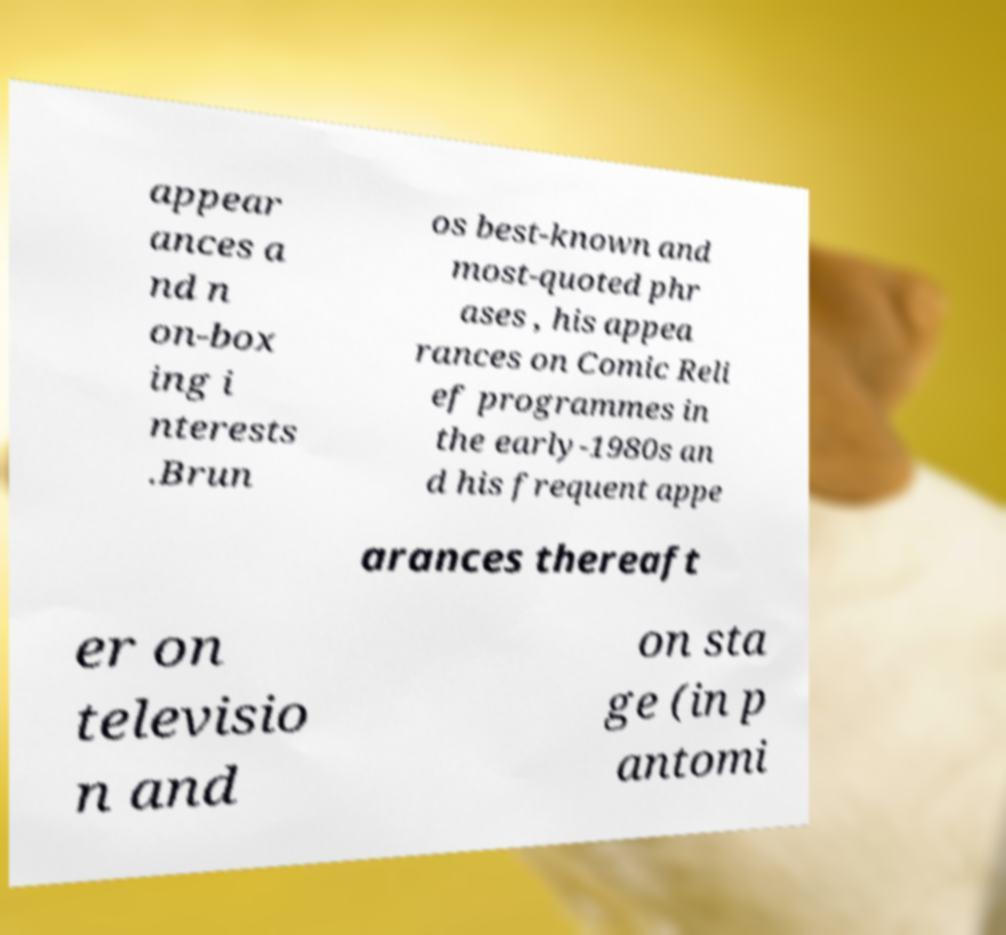Please read and relay the text visible in this image. What does it say? appear ances a nd n on-box ing i nterests .Brun os best-known and most-quoted phr ases , his appea rances on Comic Reli ef programmes in the early-1980s an d his frequent appe arances thereaft er on televisio n and on sta ge (in p antomi 